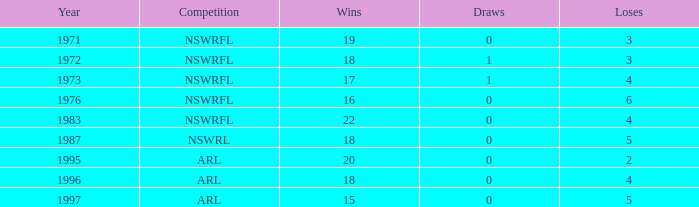What total of losses has year exceeding 1972, and contest of nswrfl, and draws 0, and victories 16? 6.0. 